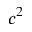<formula> <loc_0><loc_0><loc_500><loc_500>c ^ { 2 }</formula> 